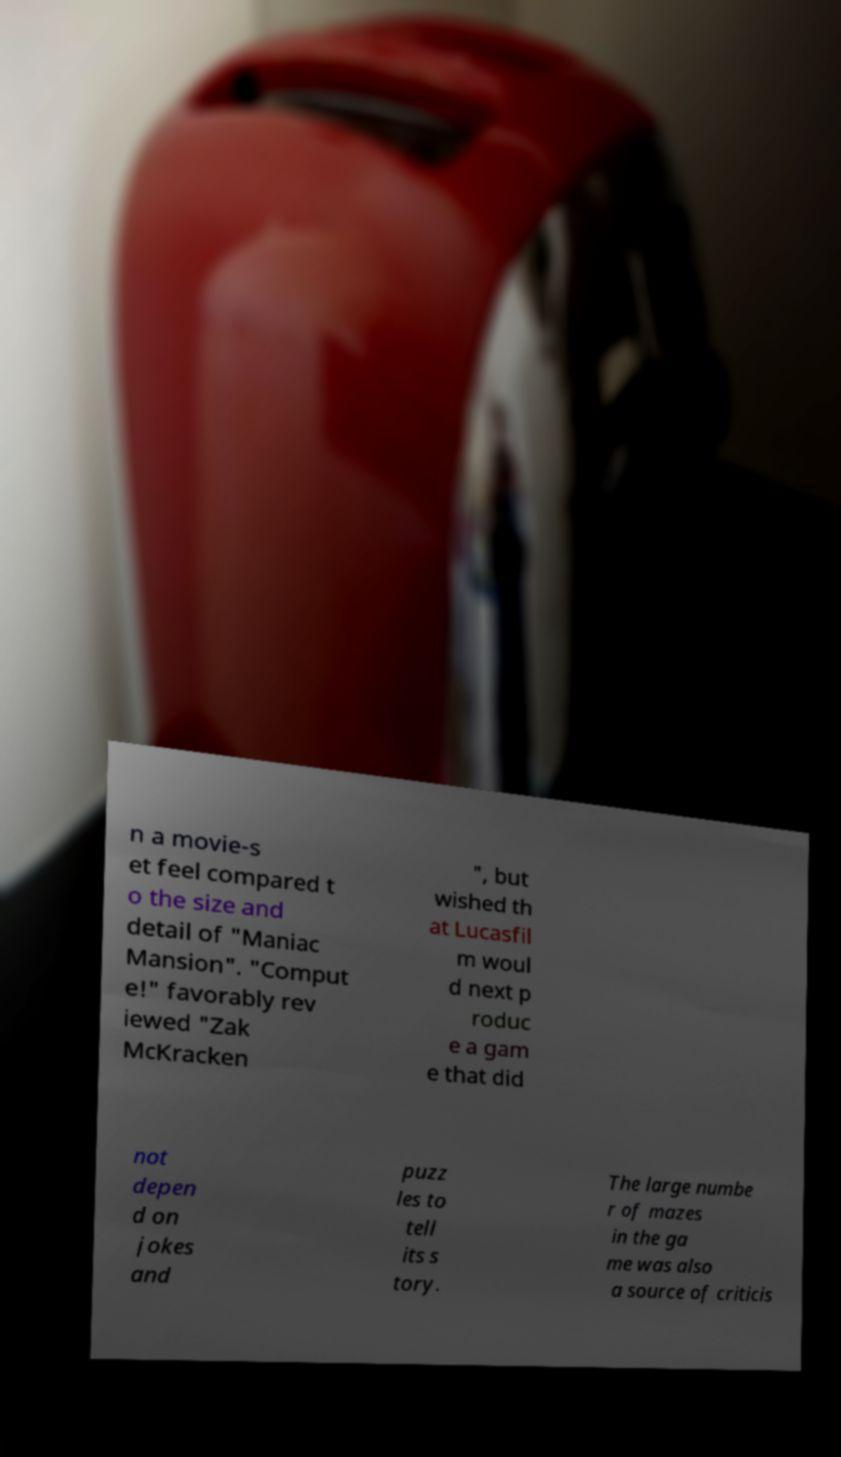Could you extract and type out the text from this image? n a movie-s et feel compared t o the size and detail of "Maniac Mansion". "Comput e!" favorably rev iewed "Zak McKracken ", but wished th at Lucasfil m woul d next p roduc e a gam e that did not depen d on jokes and puzz les to tell its s tory. The large numbe r of mazes in the ga me was also a source of criticis 